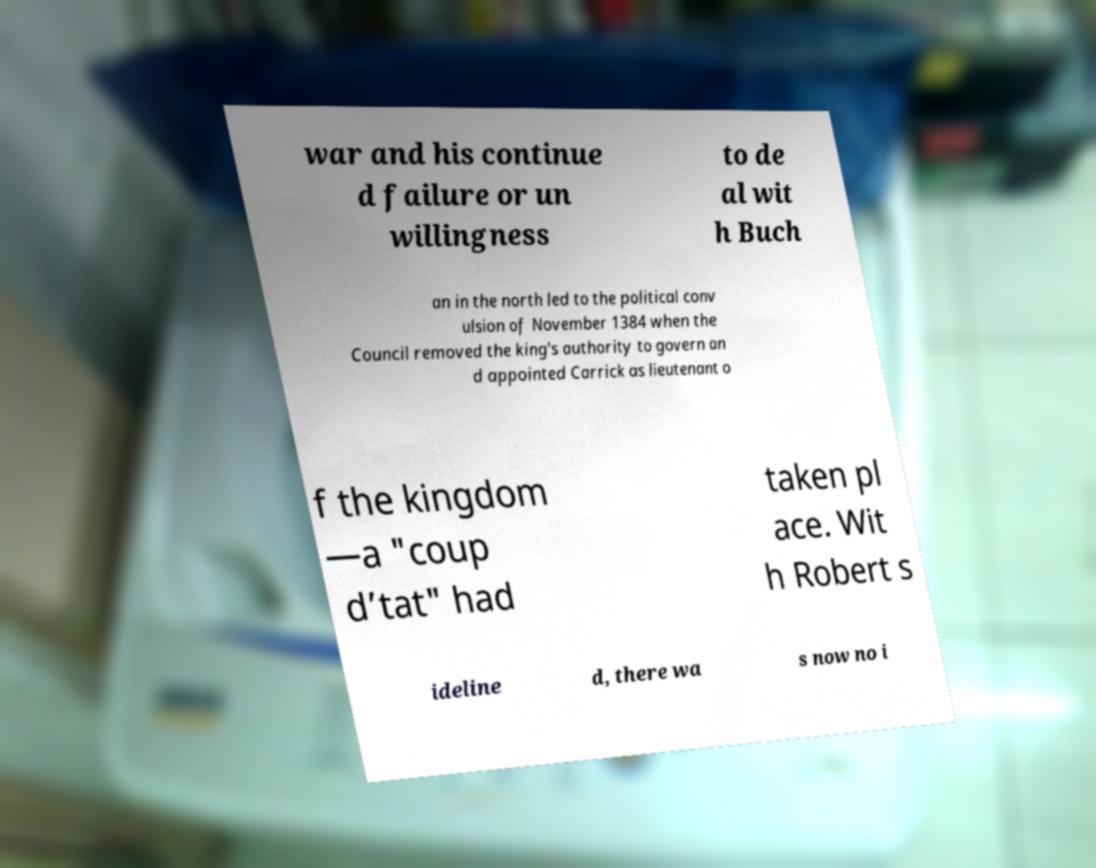Can you read and provide the text displayed in the image?This photo seems to have some interesting text. Can you extract and type it out for me? war and his continue d failure or un willingness to de al wit h Buch an in the north led to the political conv ulsion of November 1384 when the Council removed the king's authority to govern an d appointed Carrick as lieutenant o f the kingdom —a "coup d’tat" had taken pl ace. Wit h Robert s ideline d, there wa s now no i 